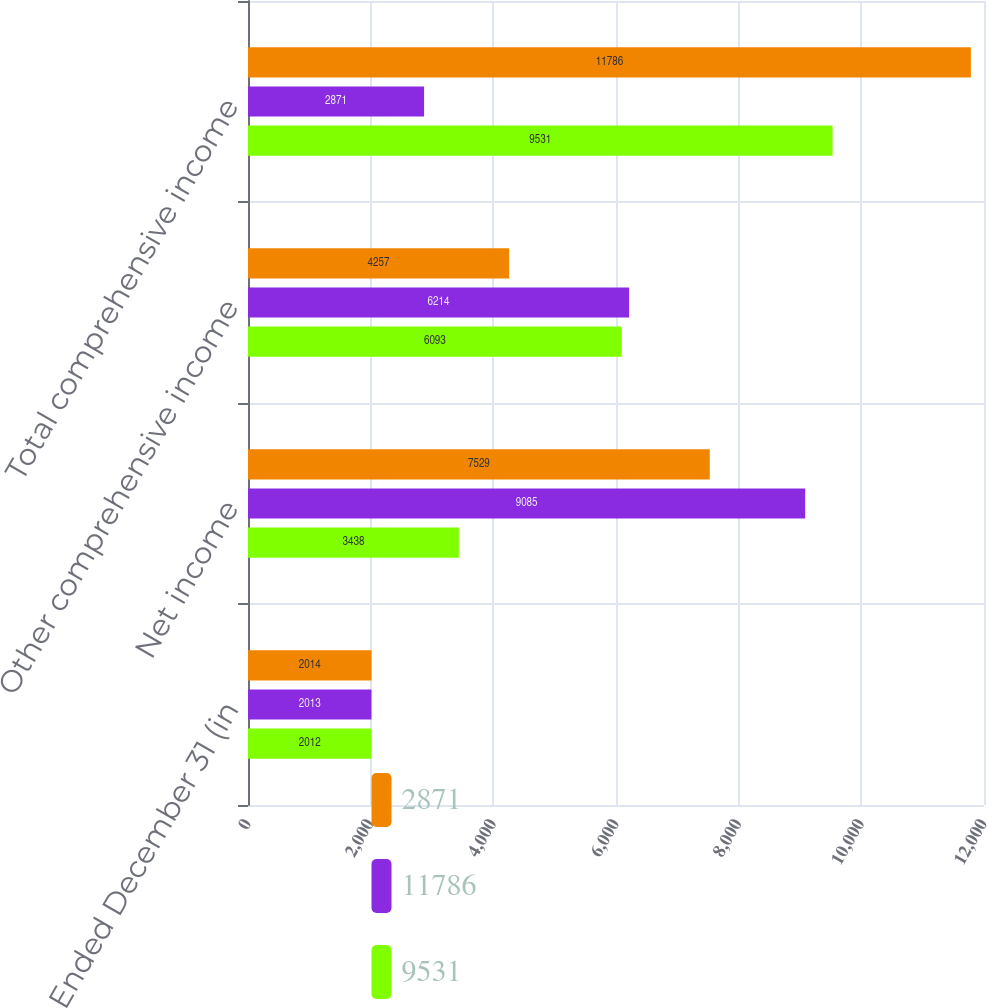Convert chart to OTSL. <chart><loc_0><loc_0><loc_500><loc_500><stacked_bar_chart><ecel><fcel>Years Ended December 31 (in<fcel>Net income<fcel>Other comprehensive income<fcel>Total comprehensive income<nl><fcel>2871<fcel>2014<fcel>7529<fcel>4257<fcel>11786<nl><fcel>11786<fcel>2013<fcel>9085<fcel>6214<fcel>2871<nl><fcel>9531<fcel>2012<fcel>3438<fcel>6093<fcel>9531<nl></chart> 